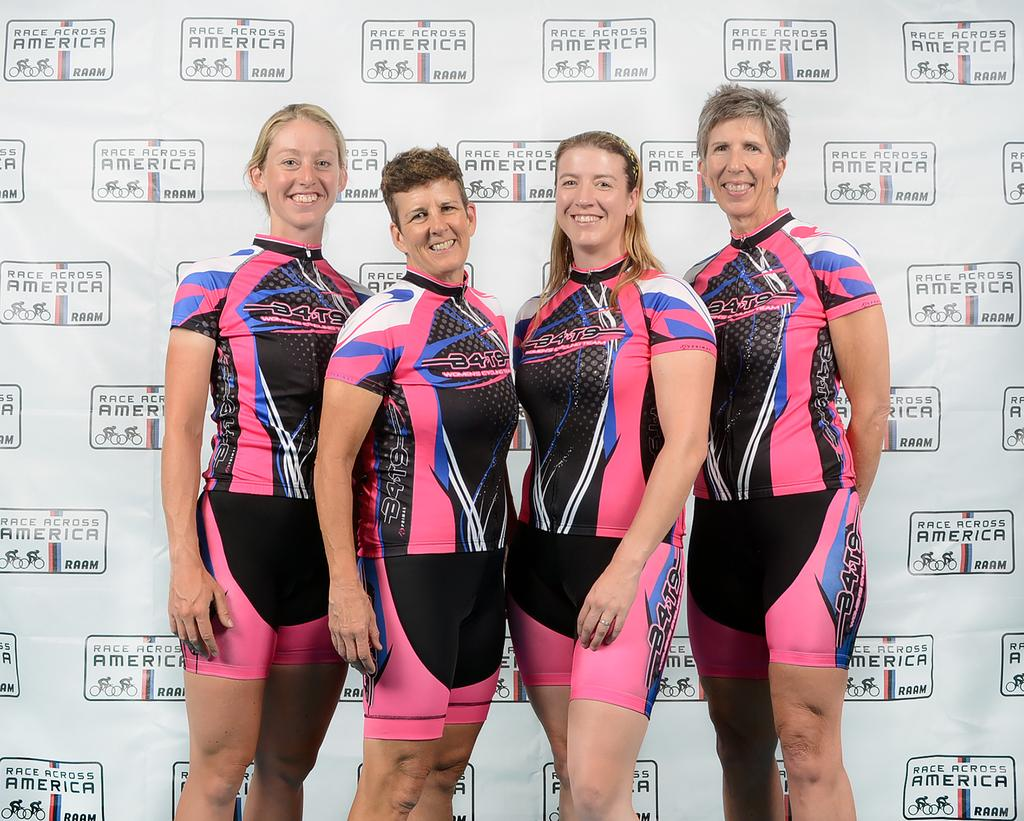<image>
Summarize the visual content of the image. A number of sportswomen; their shirts read A4T9. 